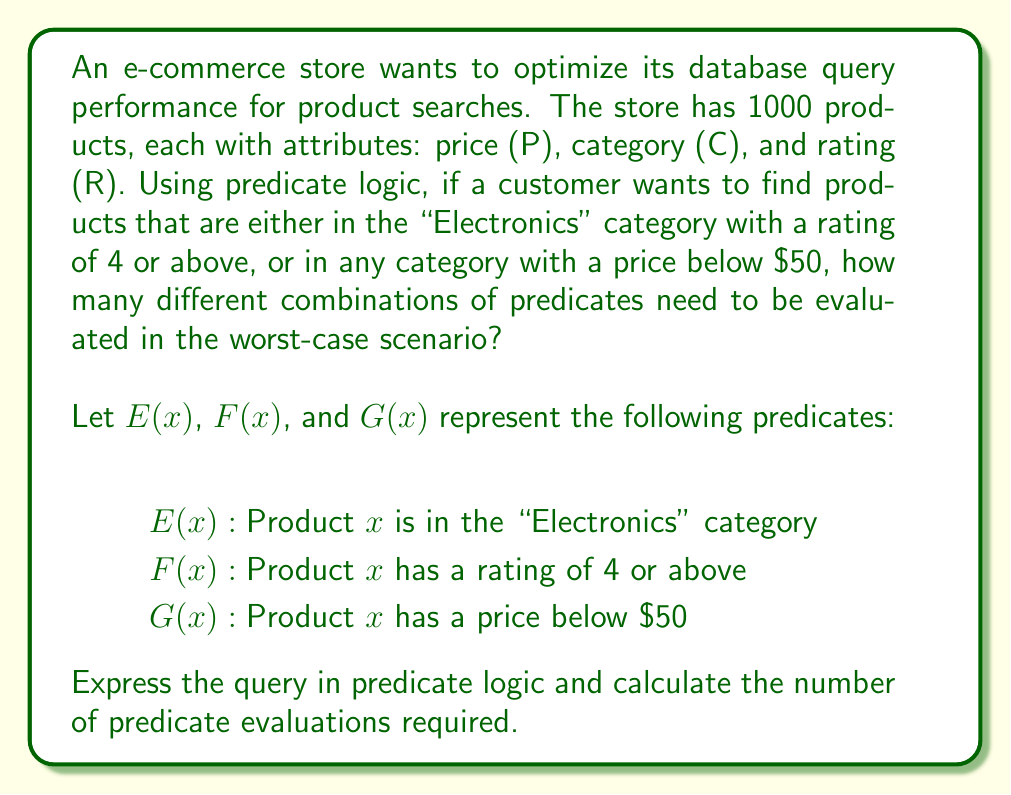Solve this math problem. To solve this problem, we need to follow these steps:

1. Express the query in predicate logic:
   The query can be represented as: $$(E(x) \wedge F(x)) \vee G(x)$$

2. Analyze the predicates:
   - $E(x)$: Category check (Electronics or not)
   - $F(x)$: Rating check (4 or above)
   - $G(x)$: Price check (below $50)

3. Consider the worst-case scenario:
   In the worst case, we need to evaluate all predicates for all products.

4. Calculate the number of predicate evaluations:
   - For each product, we need to evaluate $E(x)$, $F(x)$, and $G(x)$.
   - There are 3 predicates per product.
   - The store has 1000 products.

   Therefore, the total number of predicate evaluations is:
   $$3 \times 1000 = 3000$$

This approach allows the database to efficiently filter products based on the given criteria, potentially using indexes on the category, rating, and price fields to speed up the query execution.
Answer: 3000 predicate evaluations 